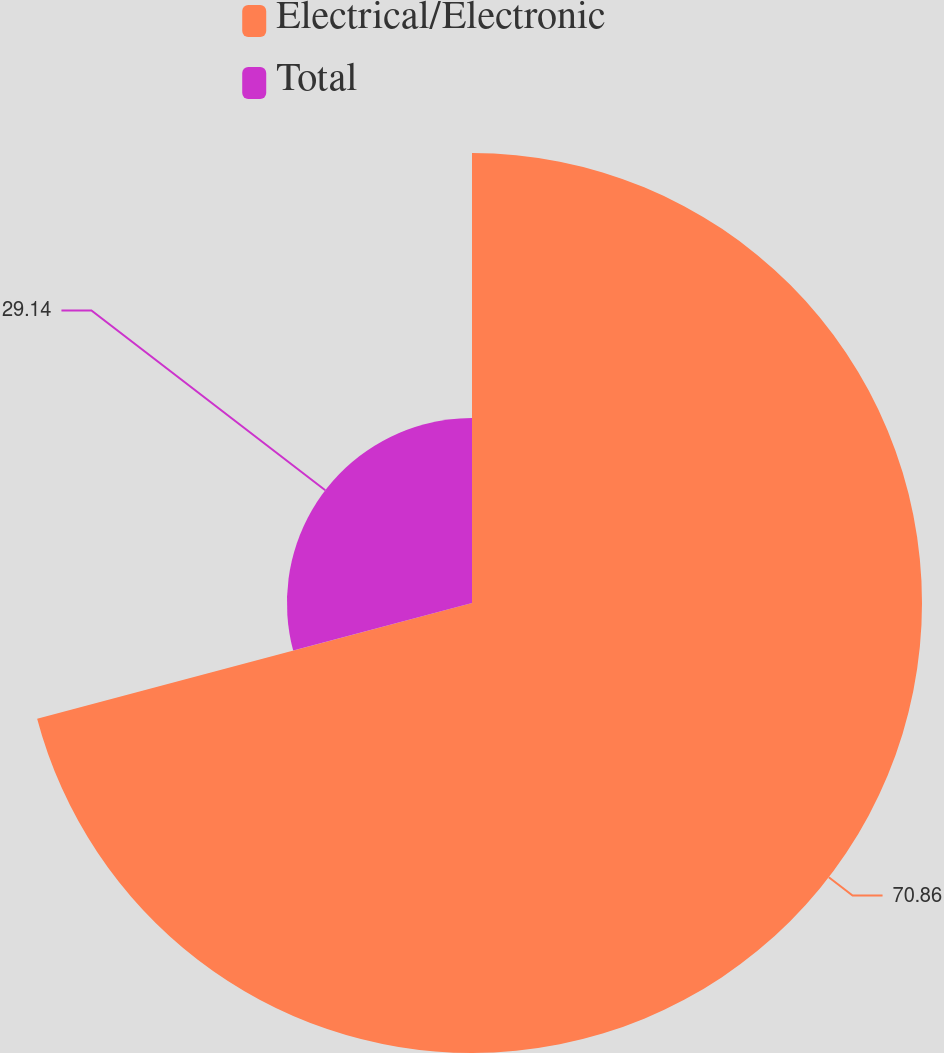Convert chart to OTSL. <chart><loc_0><loc_0><loc_500><loc_500><pie_chart><fcel>Electrical/Electronic<fcel>Total<nl><fcel>70.86%<fcel>29.14%<nl></chart> 